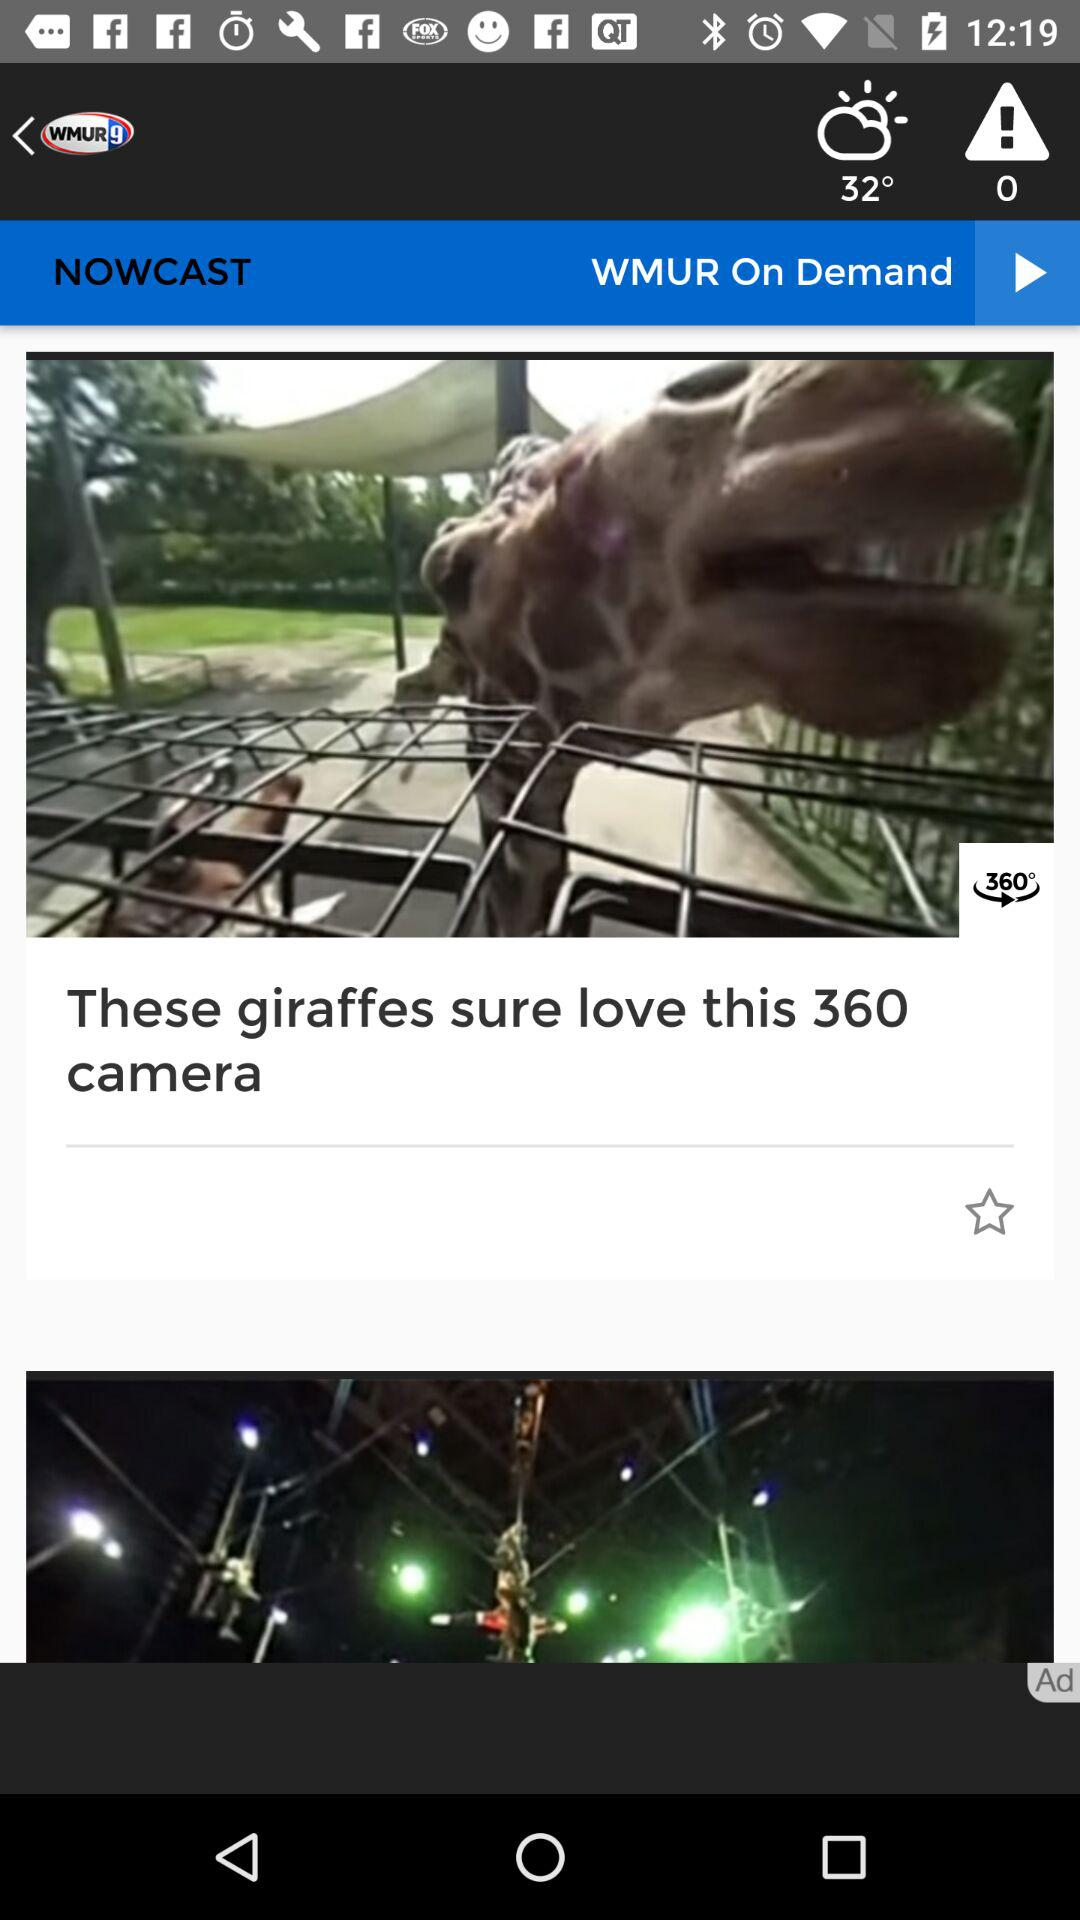What is the camera angle? The camera angle is 360°. 